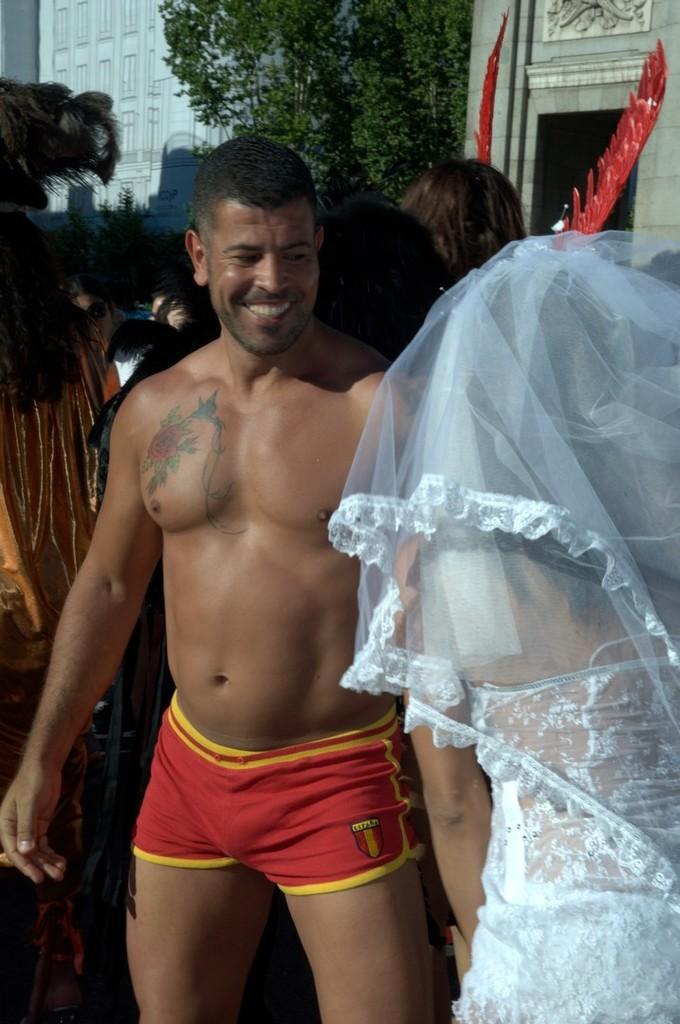In one or two sentences, can you explain what this image depicts? On the right there is a woman in bridal dress. In the center of the picture there is a person standing. In the background there are trees, building, people and other objects. 